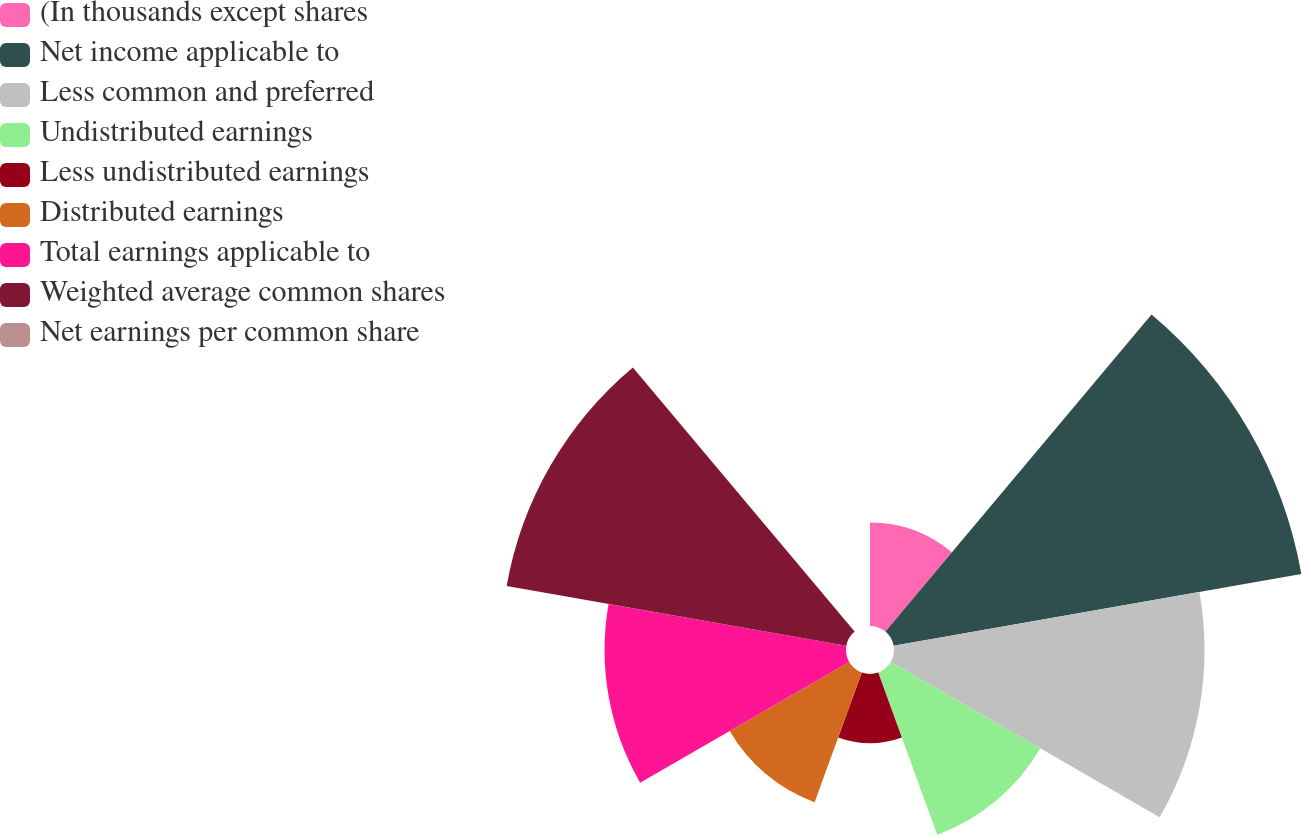Convert chart to OTSL. <chart><loc_0><loc_0><loc_500><loc_500><pie_chart><fcel>(In thousands except shares<fcel>Net income applicable to<fcel>Less common and preferred<fcel>Undistributed earnings<fcel>Less undistributed earnings<fcel>Distributed earnings<fcel>Total earnings applicable to<fcel>Weighted average common shares<fcel>Net earnings per common share<nl><fcel>5.77%<fcel>23.08%<fcel>17.31%<fcel>9.62%<fcel>3.85%<fcel>7.69%<fcel>13.46%<fcel>19.23%<fcel>0.0%<nl></chart> 